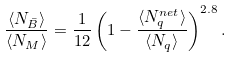Convert formula to latex. <formula><loc_0><loc_0><loc_500><loc_500>\frac { \langle N _ { \bar { B } } \rangle } { \langle N _ { M } \rangle } = \frac { 1 } { 1 2 } \left ( 1 - \frac { \langle N _ { q } ^ { n e t } \rangle } { \langle N _ { q } \rangle } \right ) ^ { 2 . 8 } .</formula> 